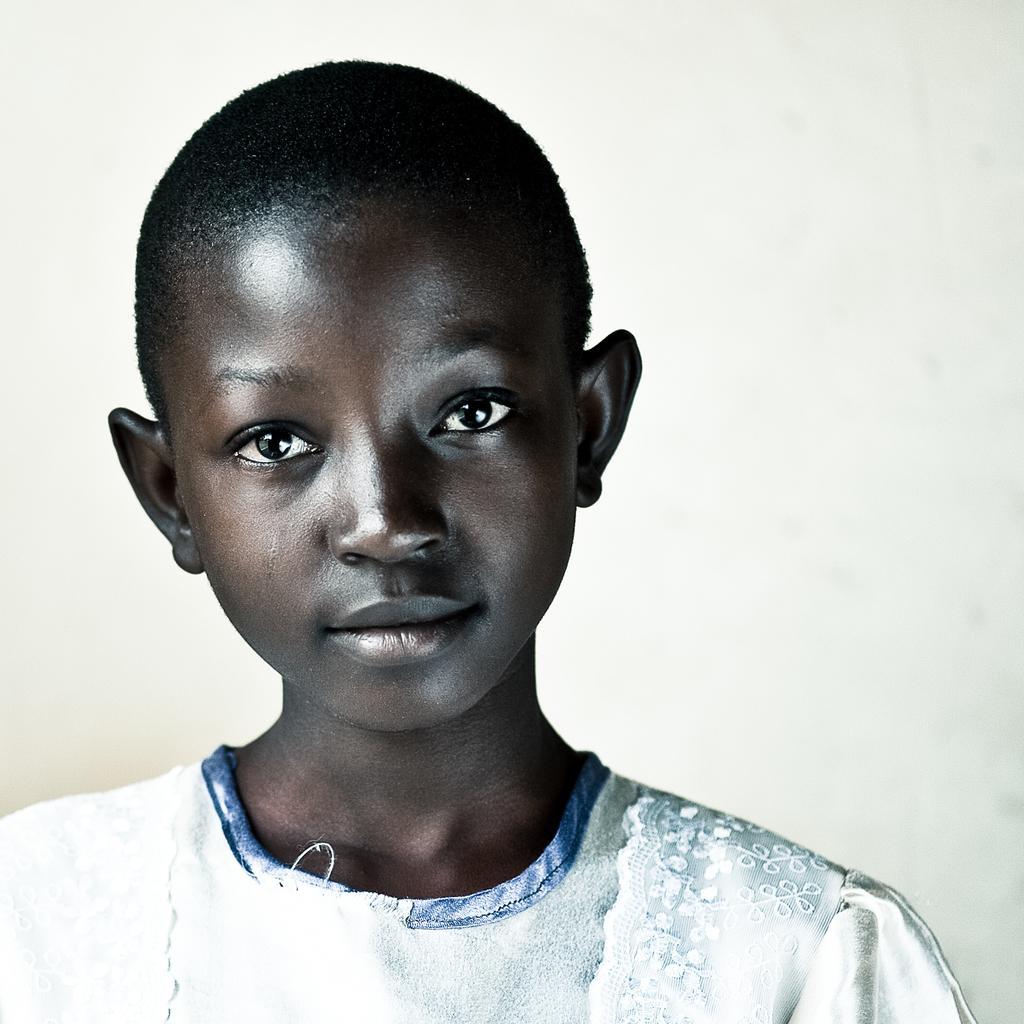Can you describe this image briefly? In this image there is a person wearing white dress. The background is white. 